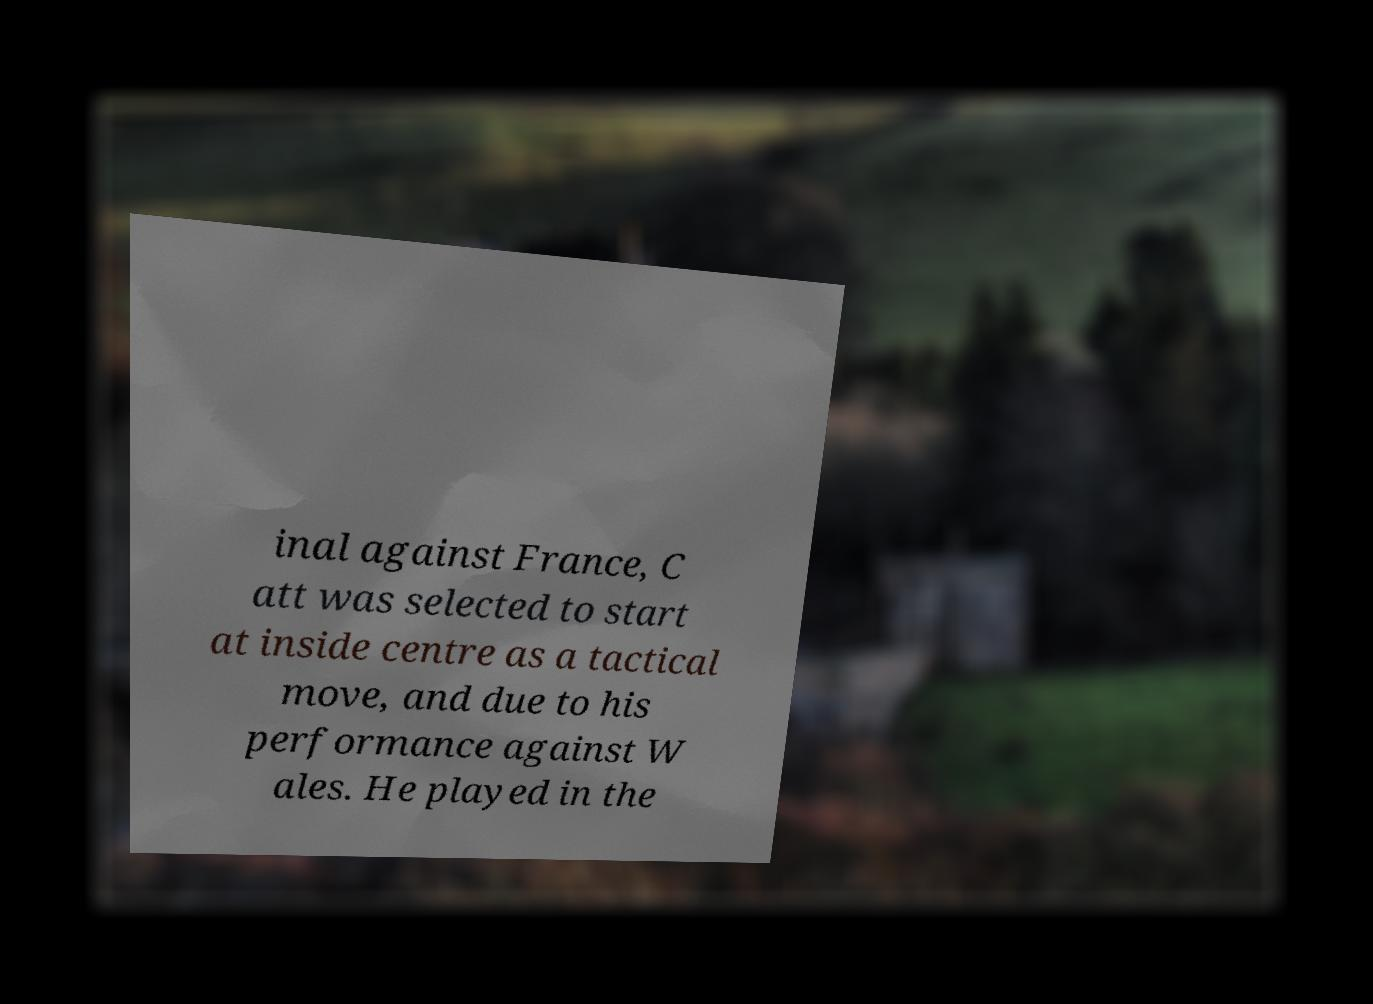Please identify and transcribe the text found in this image. inal against France, C att was selected to start at inside centre as a tactical move, and due to his performance against W ales. He played in the 